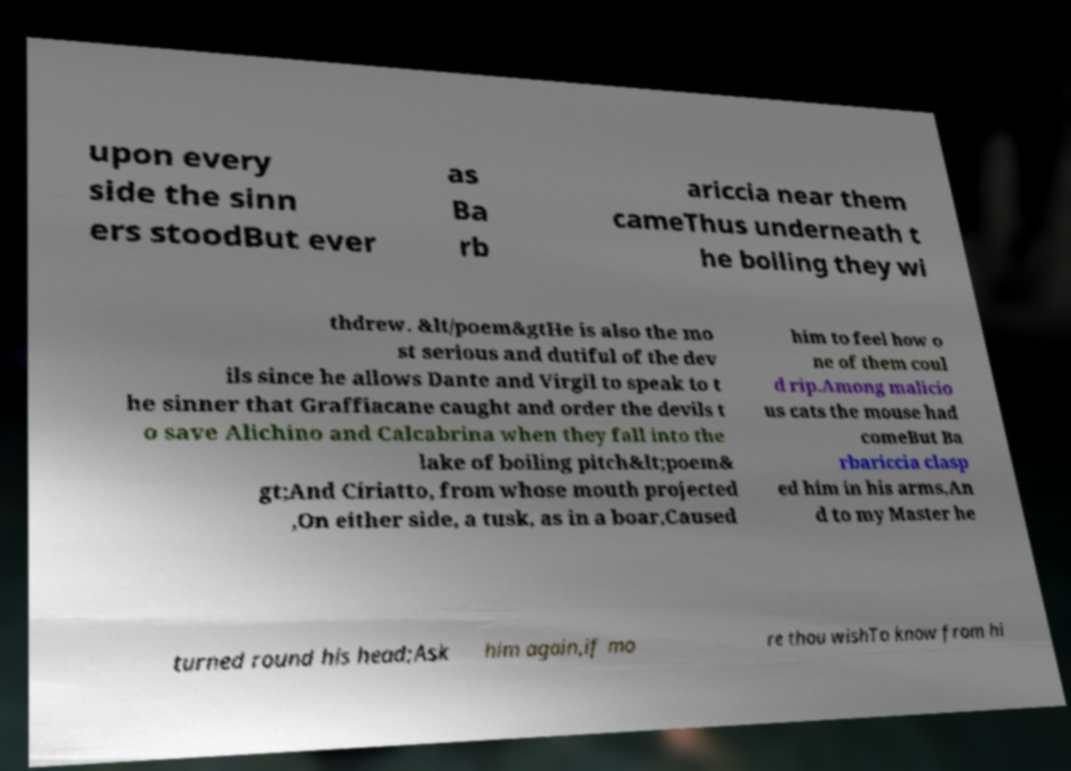Could you extract and type out the text from this image? upon every side the sinn ers stoodBut ever as Ba rb ariccia near them cameThus underneath t he boiling they wi thdrew. &lt/poem&gtHe is also the mo st serious and dutiful of the dev ils since he allows Dante and Virgil to speak to t he sinner that Graffiacane caught and order the devils t o save Alichino and Calcabrina when they fall into the lake of boiling pitch&lt;poem& gt;And Ciriatto, from whose mouth projected ,On either side, a tusk, as in a boar,Caused him to feel how o ne of them coul d rip.Among malicio us cats the mouse had comeBut Ba rbariccia clasp ed him in his arms,An d to my Master he turned round his head;Ask him again,if mo re thou wishTo know from hi 